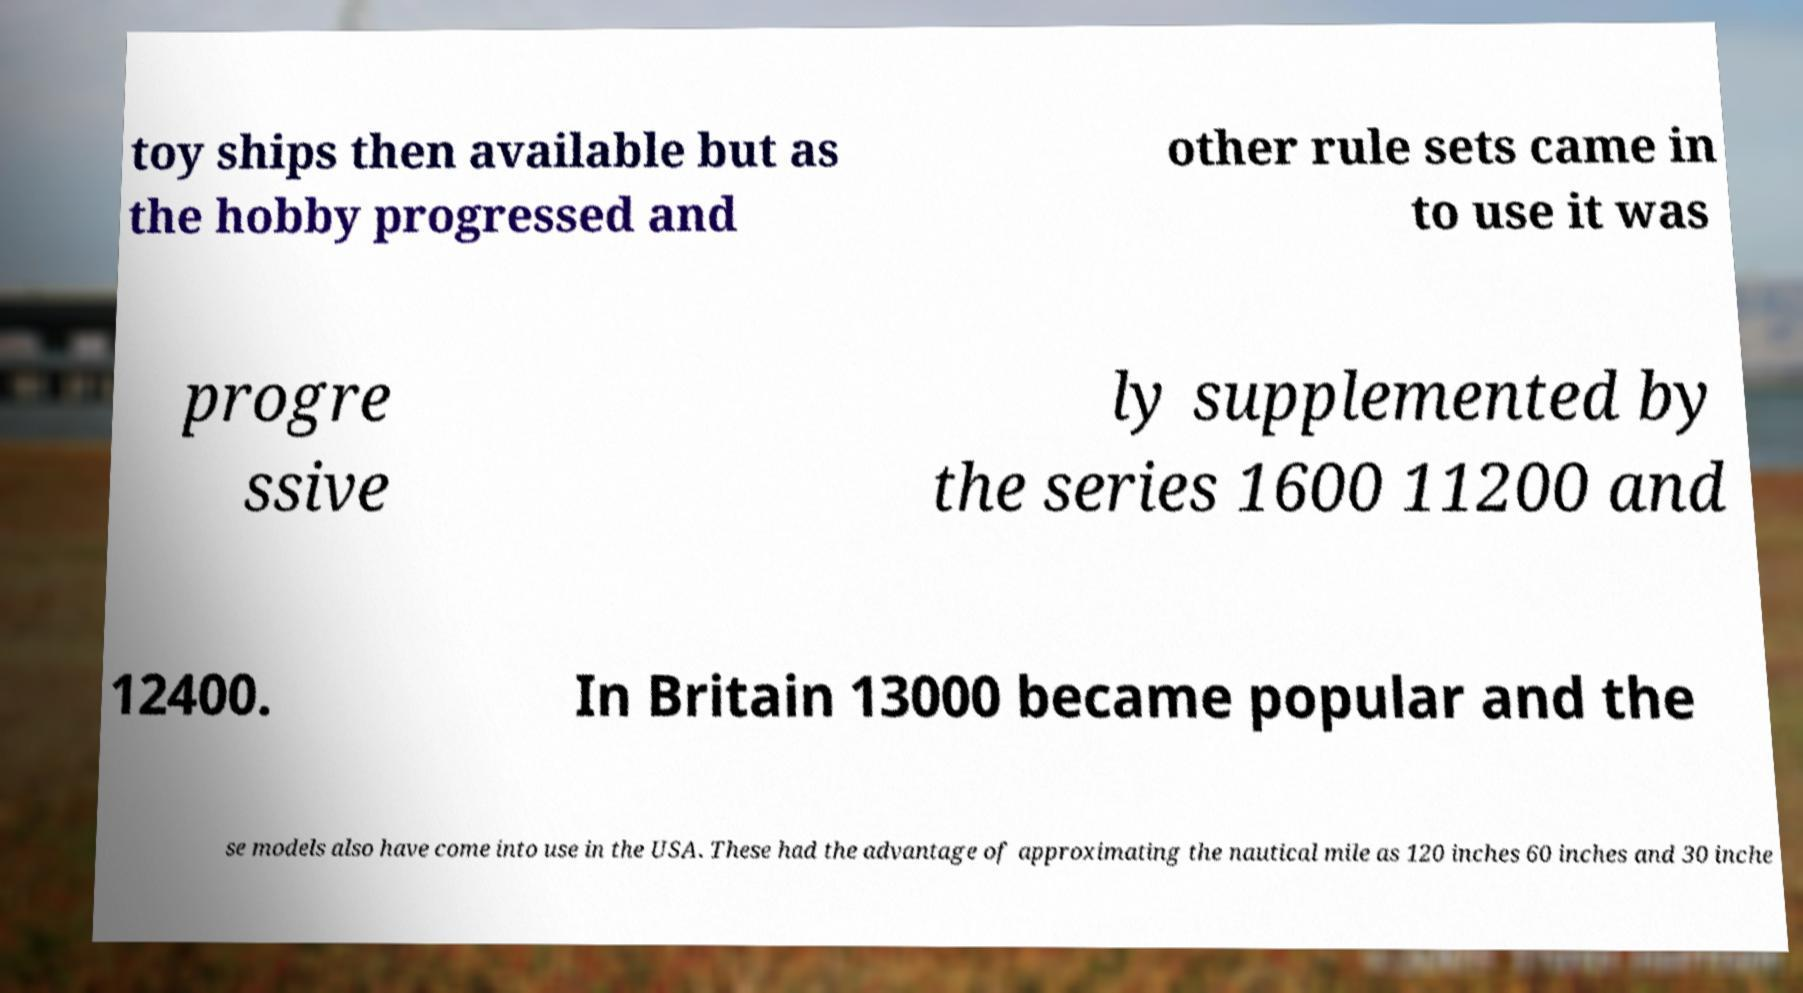Could you assist in decoding the text presented in this image and type it out clearly? toy ships then available but as the hobby progressed and other rule sets came in to use it was progre ssive ly supplemented by the series 1600 11200 and 12400. In Britain 13000 became popular and the se models also have come into use in the USA. These had the advantage of approximating the nautical mile as 120 inches 60 inches and 30 inche 